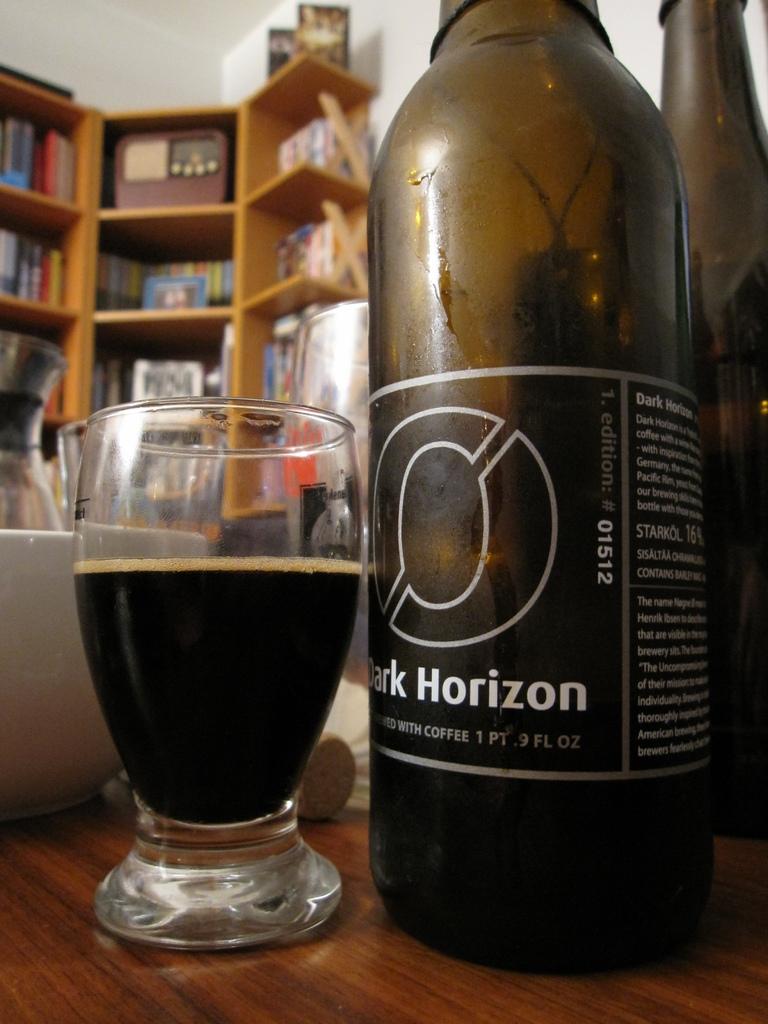How many ounces is the bottle?
Offer a terse response. 9. What brand of bottle?
Give a very brief answer. Dark horizon. 